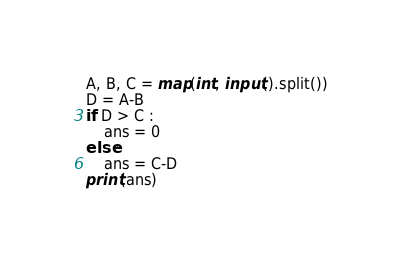Convert code to text. <code><loc_0><loc_0><loc_500><loc_500><_Python_>A, B, C = map(int, input().split())
D = A-B
if D > C :
    ans = 0
else:
    ans = C-D
print(ans)</code> 